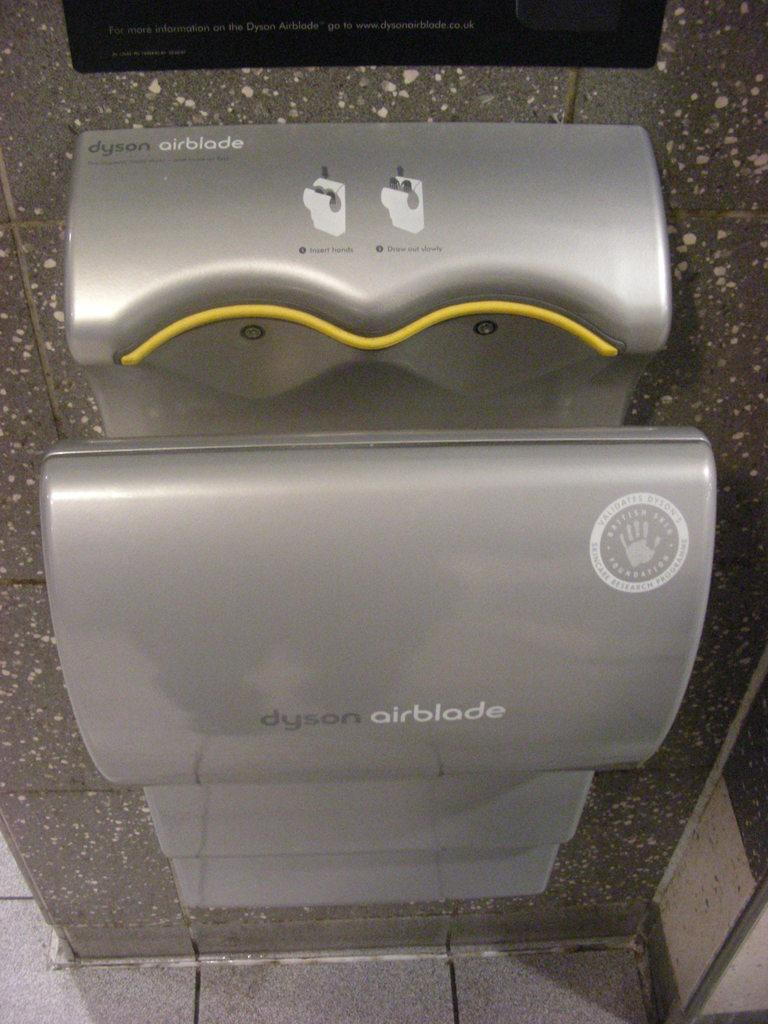What can be found on the wall in the image? There is a hand dryer on the wall in the image. What part of the room can be seen in the image? The floor is visible in the image. What song is being played by the hand dryer in the image? The hand dryer in the image is not a musical instrument and does not play songs. 